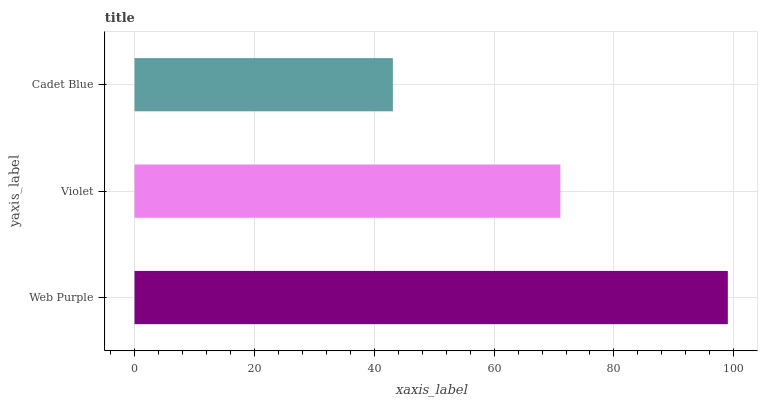Is Cadet Blue the minimum?
Answer yes or no. Yes. Is Web Purple the maximum?
Answer yes or no. Yes. Is Violet the minimum?
Answer yes or no. No. Is Violet the maximum?
Answer yes or no. No. Is Web Purple greater than Violet?
Answer yes or no. Yes. Is Violet less than Web Purple?
Answer yes or no. Yes. Is Violet greater than Web Purple?
Answer yes or no. No. Is Web Purple less than Violet?
Answer yes or no. No. Is Violet the high median?
Answer yes or no. Yes. Is Violet the low median?
Answer yes or no. Yes. Is Cadet Blue the high median?
Answer yes or no. No. Is Cadet Blue the low median?
Answer yes or no. No. 